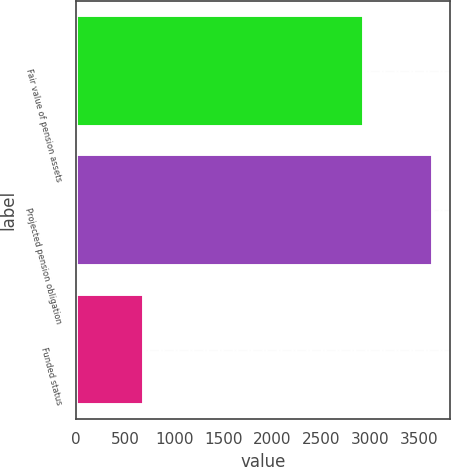Convert chart to OTSL. <chart><loc_0><loc_0><loc_500><loc_500><bar_chart><fcel>Fair value of pension assets<fcel>Projected pension obligation<fcel>Funded status<nl><fcel>2944<fcel>3640<fcel>696<nl></chart> 